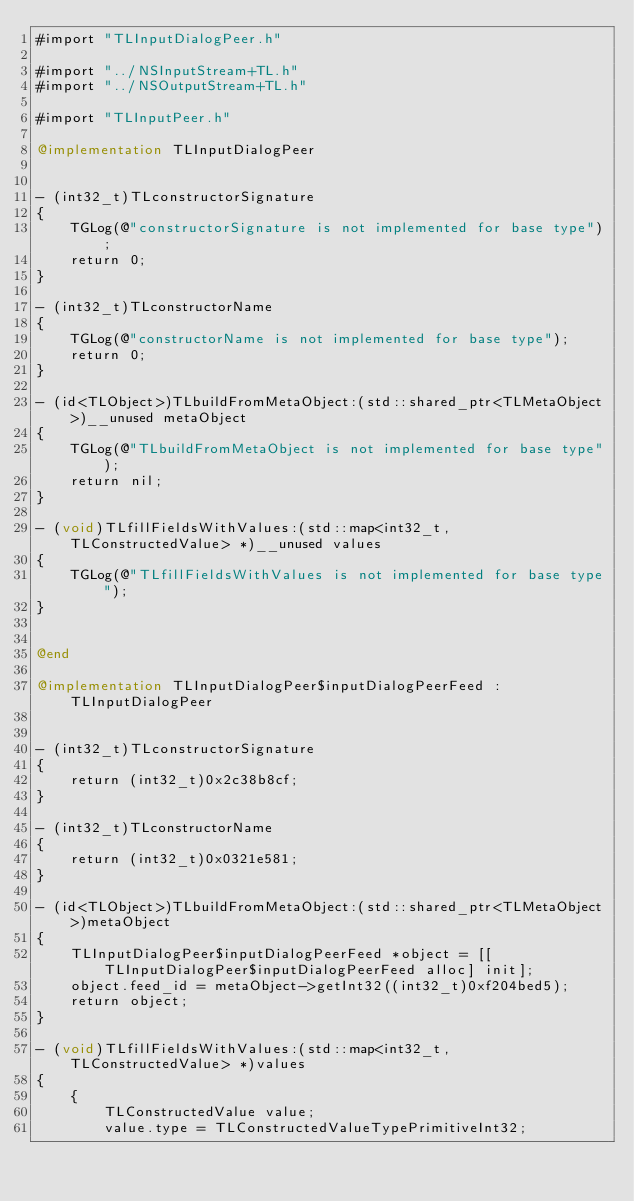<code> <loc_0><loc_0><loc_500><loc_500><_ObjectiveC_>#import "TLInputDialogPeer.h"

#import "../NSInputStream+TL.h"
#import "../NSOutputStream+TL.h"

#import "TLInputPeer.h"

@implementation TLInputDialogPeer


- (int32_t)TLconstructorSignature
{
    TGLog(@"constructorSignature is not implemented for base type");
    return 0;
}

- (int32_t)TLconstructorName
{
    TGLog(@"constructorName is not implemented for base type");
    return 0;
}

- (id<TLObject>)TLbuildFromMetaObject:(std::shared_ptr<TLMetaObject>)__unused metaObject
{
    TGLog(@"TLbuildFromMetaObject is not implemented for base type");
    return nil;
}

- (void)TLfillFieldsWithValues:(std::map<int32_t, TLConstructedValue> *)__unused values
{
    TGLog(@"TLfillFieldsWithValues is not implemented for base type");
}


@end

@implementation TLInputDialogPeer$inputDialogPeerFeed : TLInputDialogPeer


- (int32_t)TLconstructorSignature
{
    return (int32_t)0x2c38b8cf;
}

- (int32_t)TLconstructorName
{
    return (int32_t)0x0321e581;
}

- (id<TLObject>)TLbuildFromMetaObject:(std::shared_ptr<TLMetaObject>)metaObject
{
    TLInputDialogPeer$inputDialogPeerFeed *object = [[TLInputDialogPeer$inputDialogPeerFeed alloc] init];
    object.feed_id = metaObject->getInt32((int32_t)0xf204bed5);
    return object;
}

- (void)TLfillFieldsWithValues:(std::map<int32_t, TLConstructedValue> *)values
{
    {
        TLConstructedValue value;
        value.type = TLConstructedValueTypePrimitiveInt32;</code> 